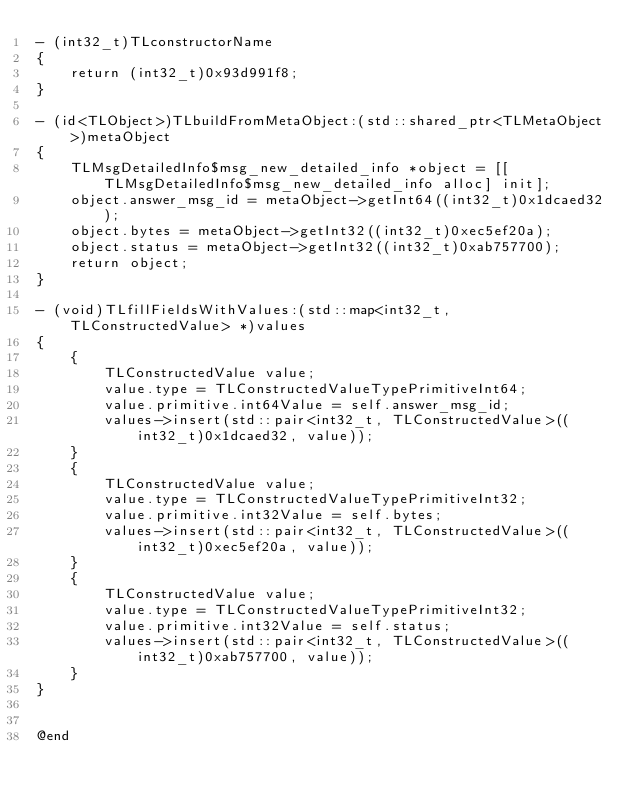<code> <loc_0><loc_0><loc_500><loc_500><_ObjectiveC_>- (int32_t)TLconstructorName
{
    return (int32_t)0x93d991f8;
}

- (id<TLObject>)TLbuildFromMetaObject:(std::shared_ptr<TLMetaObject>)metaObject
{
    TLMsgDetailedInfo$msg_new_detailed_info *object = [[TLMsgDetailedInfo$msg_new_detailed_info alloc] init];
    object.answer_msg_id = metaObject->getInt64((int32_t)0x1dcaed32);
    object.bytes = metaObject->getInt32((int32_t)0xec5ef20a);
    object.status = metaObject->getInt32((int32_t)0xab757700);
    return object;
}

- (void)TLfillFieldsWithValues:(std::map<int32_t, TLConstructedValue> *)values
{
    {
        TLConstructedValue value;
        value.type = TLConstructedValueTypePrimitiveInt64;
        value.primitive.int64Value = self.answer_msg_id;
        values->insert(std::pair<int32_t, TLConstructedValue>((int32_t)0x1dcaed32, value));
    }
    {
        TLConstructedValue value;
        value.type = TLConstructedValueTypePrimitiveInt32;
        value.primitive.int32Value = self.bytes;
        values->insert(std::pair<int32_t, TLConstructedValue>((int32_t)0xec5ef20a, value));
    }
    {
        TLConstructedValue value;
        value.type = TLConstructedValueTypePrimitiveInt32;
        value.primitive.int32Value = self.status;
        values->insert(std::pair<int32_t, TLConstructedValue>((int32_t)0xab757700, value));
    }
}


@end

</code> 